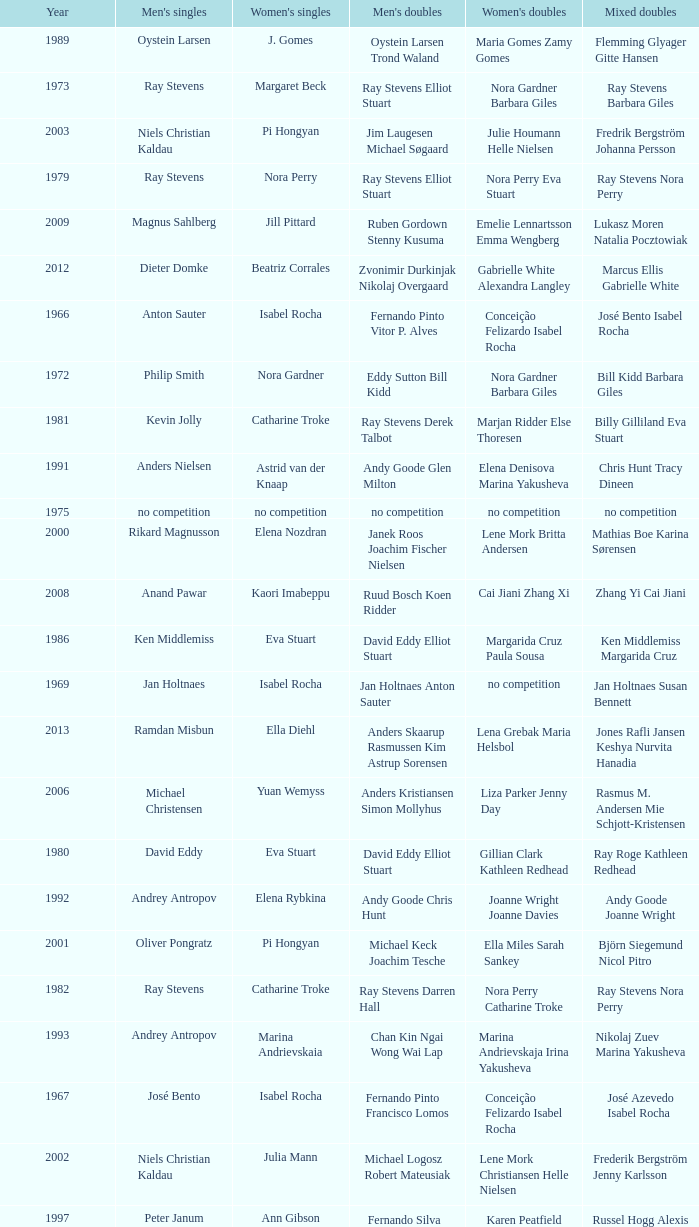What is the average year with alfredo salazar fina salazar in mixed doubles? 1971.0. 